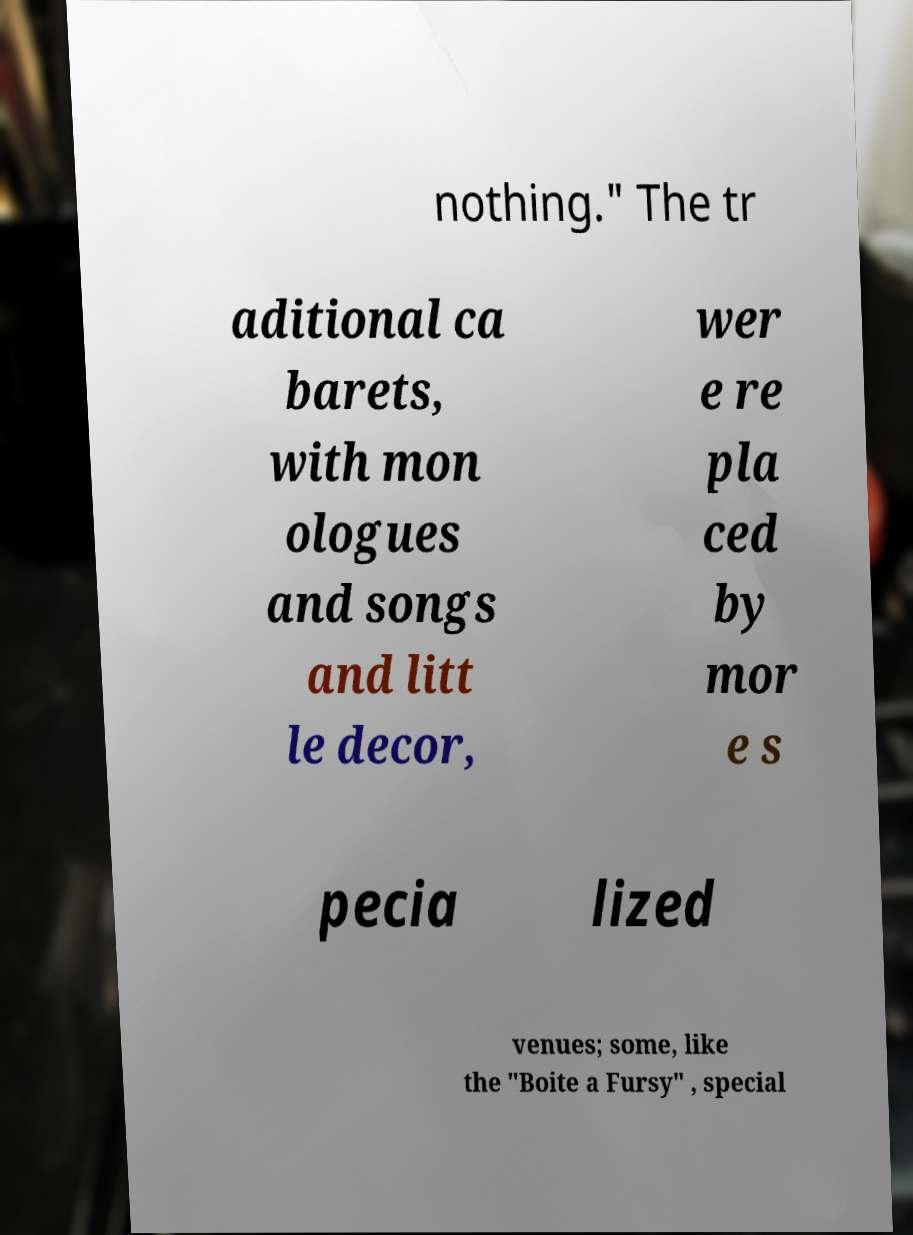Could you assist in decoding the text presented in this image and type it out clearly? nothing." The tr aditional ca barets, with mon ologues and songs and litt le decor, wer e re pla ced by mor e s pecia lized venues; some, like the "Boite a Fursy" , special 